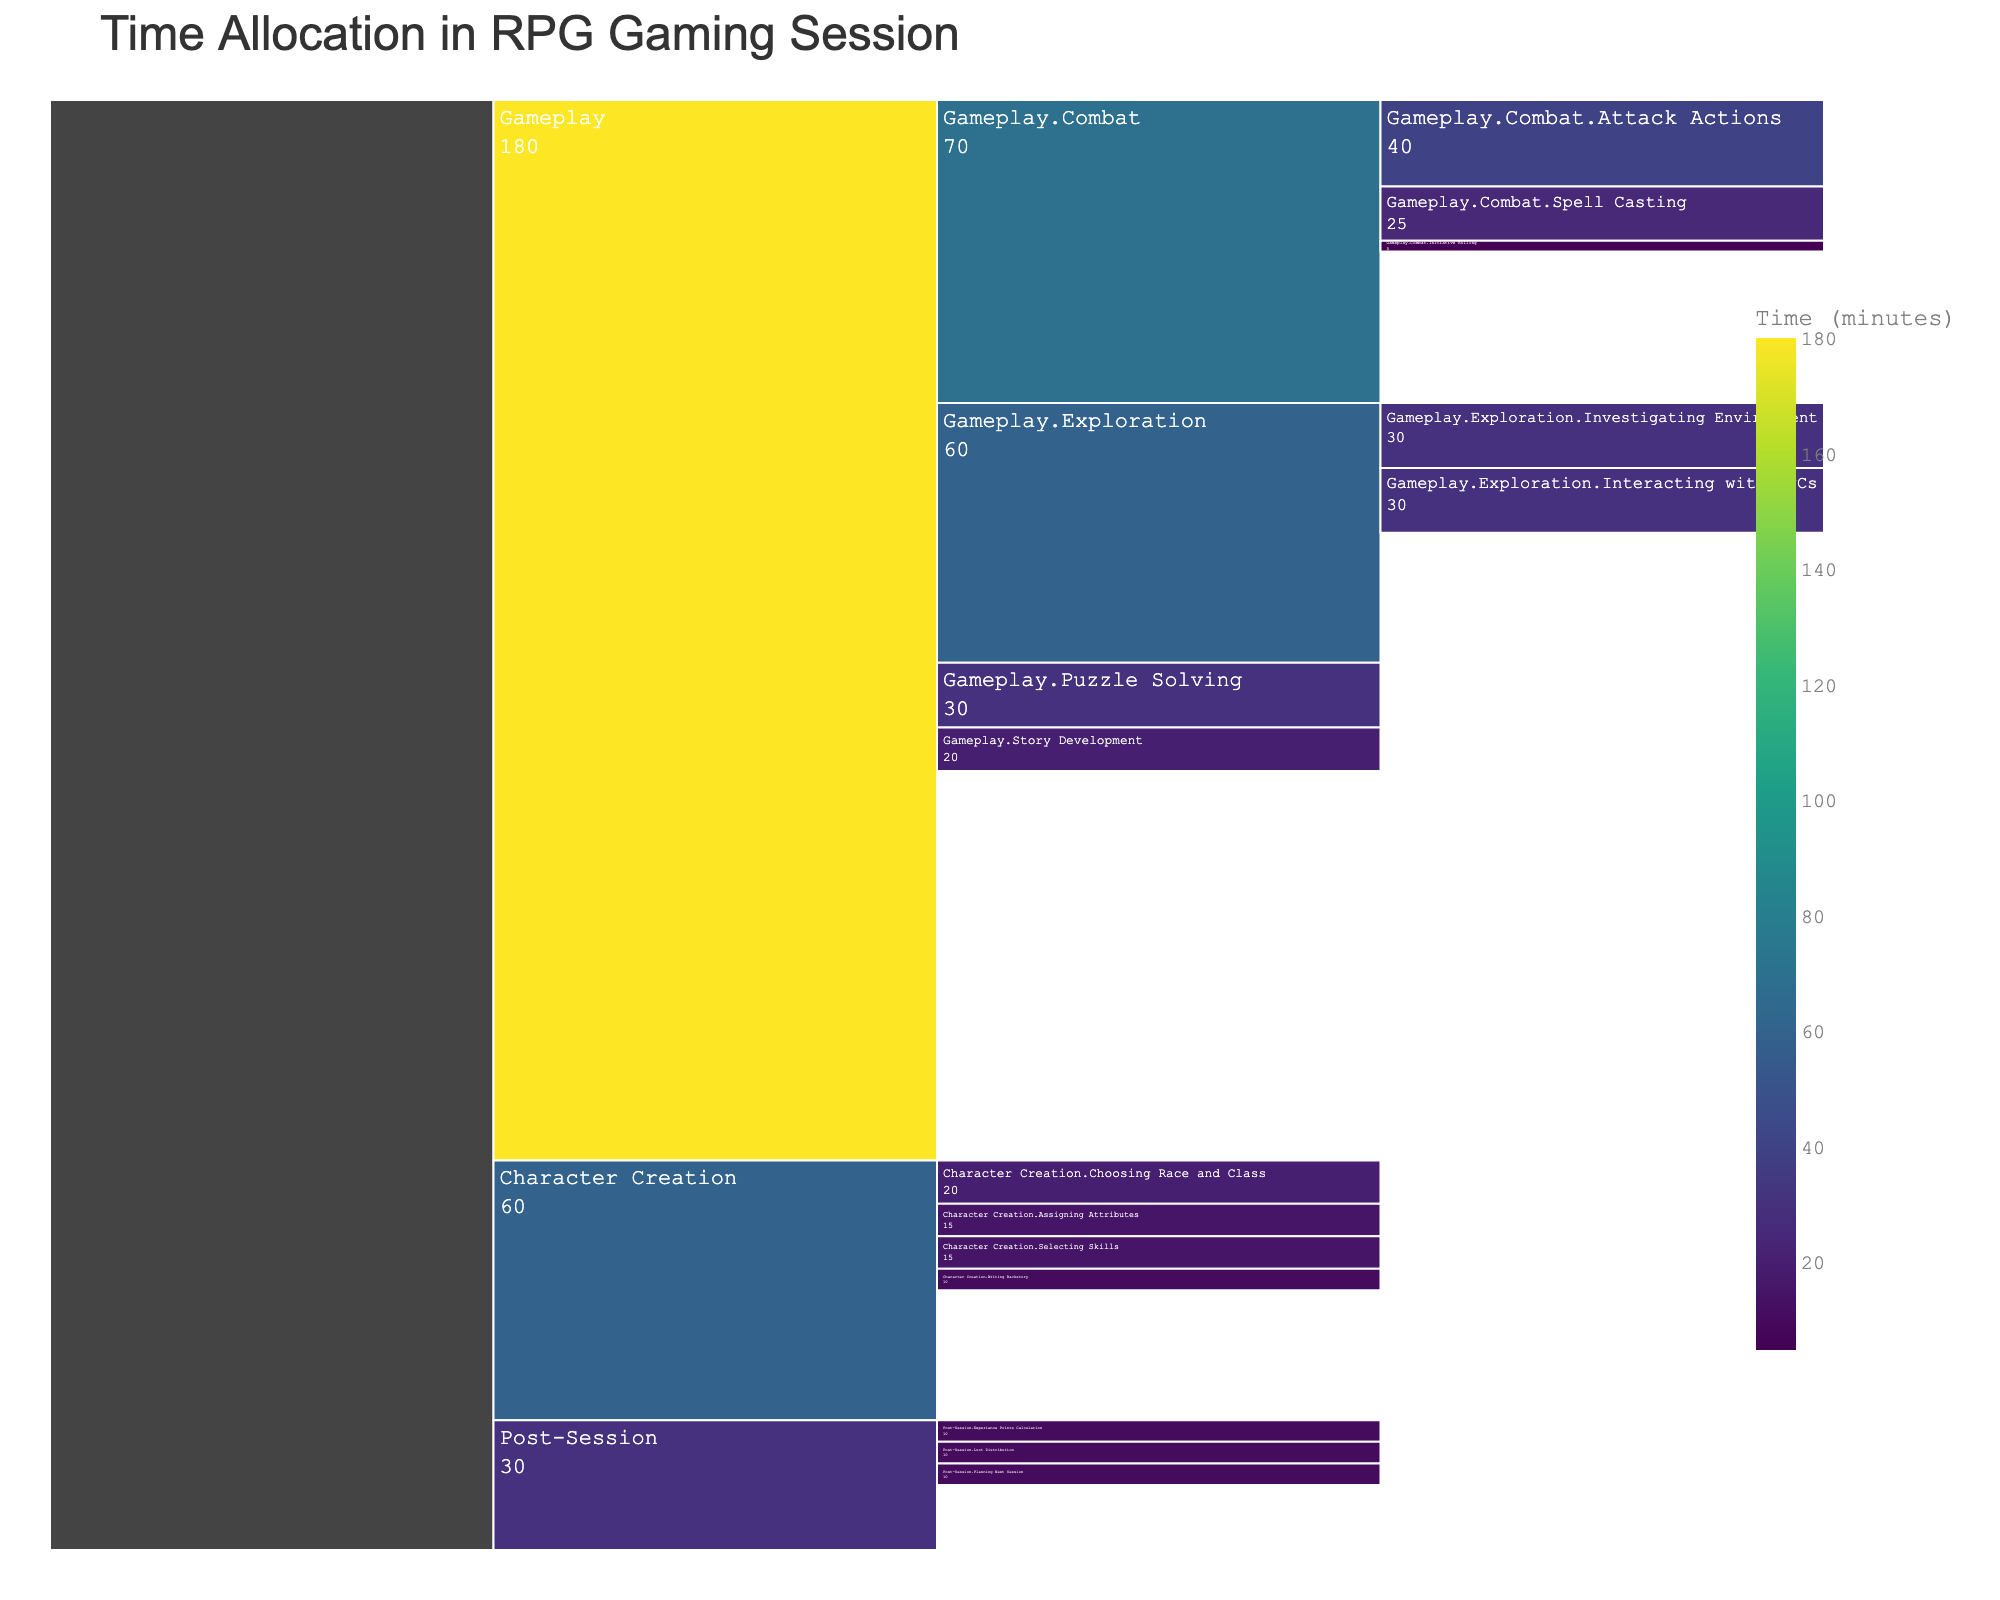What is the total time allocated to Character Creation? The total time for Character Creation is the sum of all its subcategories. These are: Choosing Race and Class (20), Assigning Attributes (15), Selecting Skills (15), and Writing Backstory (10). So, 20 + 15 + 15 + 10 = 60 minutes.
Answer: 60 minutes Which activity within Gameplay consumes the most time? Within Gameplay, the sub-activities are Exploration (60), Combat (70), Puzzle Solving (30), and Story Development (20). Among these, Combat (70 minutes) takes the most time.
Answer: Combat How much time is spent on Experience Points Calculation compared to Loot Distribution in the Post-Session? Experience Points Calculation and Loot Distribution both occur in the Post-Session. According to the data, both Experience Points Calculation and Loot Distribution each consume 10 minutes, so they take equal time.
Answer: Equal time What percentage of the total session time is spent on Exploration? The total session time is the sum of Character Creation (60), Gameplay (180), and Post-Session (30) which adds up to 270 minutes. Exploration takes 60 minutes. The percentage is calculated as (60 / 270) * 100%. So, (60 / 270) * 100 ≈ 22.22%.
Answer: Approximately 22.22% During the Combat part of Gameplay, what is the combined time spent on Attack Actions and Spell Casting? In the Combat section, the time spent on Attack Actions is 40 minutes, and Spell Casting takes 25 minutes. Hence, the combined time is 40 + 25 = 65 minutes.
Answer: 65 minutes How much more time is allocated to Planning Next Session compared to Initiave Rolling within the gameplay? Planning Next Session takes 10 minutes and Initiative Rolling takes 5 minutes. The difference is 10 - 5 = 5 minutes.
Answer: 5 minutes Which sub-activity of Character Creation takes the least time? Of the sub-activities of Character Creation, Assigning Attributes (15), Choosing Race and Class (20), Selecting Skills (15), and Writing Backstory (10), Writing Backstory takes the least time.
Answer: Writing Backstory What is the average time allocated per activity in the Post-Session? The activities in the Post-Session are Experience Points Calculation (10), Loot Distribution (10), and Planning Next Session (10). The average time is the sum of these times divided by the number of activities: (10 + 10 + 10) / 3 = 30 / 3 = 10 minutes.
Answer: 10 minutes 